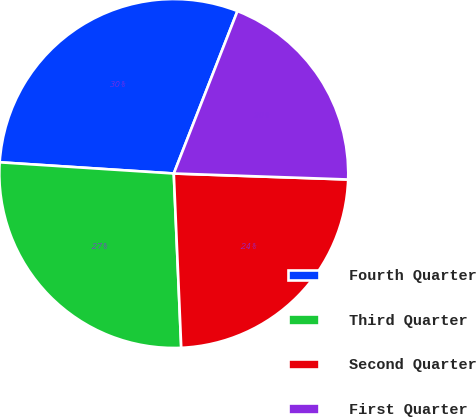<chart> <loc_0><loc_0><loc_500><loc_500><pie_chart><fcel>Fourth Quarter<fcel>Third Quarter<fcel>Second Quarter<fcel>First Quarter<nl><fcel>29.92%<fcel>26.7%<fcel>23.77%<fcel>19.6%<nl></chart> 